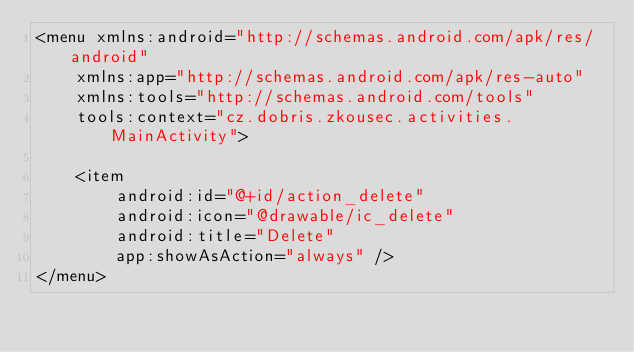Convert code to text. <code><loc_0><loc_0><loc_500><loc_500><_XML_><menu xmlns:android="http://schemas.android.com/apk/res/android"
    xmlns:app="http://schemas.android.com/apk/res-auto"
    xmlns:tools="http://schemas.android.com/tools"
    tools:context="cz.dobris.zkousec.activities.MainActivity">

    <item
        android:id="@+id/action_delete"
        android:icon="@drawable/ic_delete"
        android:title="Delete"
        app:showAsAction="always" />
</menu></code> 